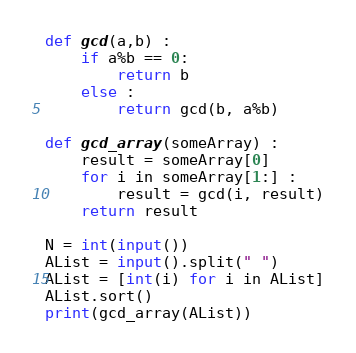Convert code to text. <code><loc_0><loc_0><loc_500><loc_500><_Python_>

def gcd(a,b) :
    if a%b == 0:
        return b
    else :
        return gcd(b, a%b)

def gcd_array(someArray) :
    result = someArray[0]
    for i in someArray[1:] :
        result = gcd(i, result)
    return result

N = int(input())
AList = input().split(" ")
AList = [int(i) for i in AList]
AList.sort()
print(gcd_array(AList))</code> 